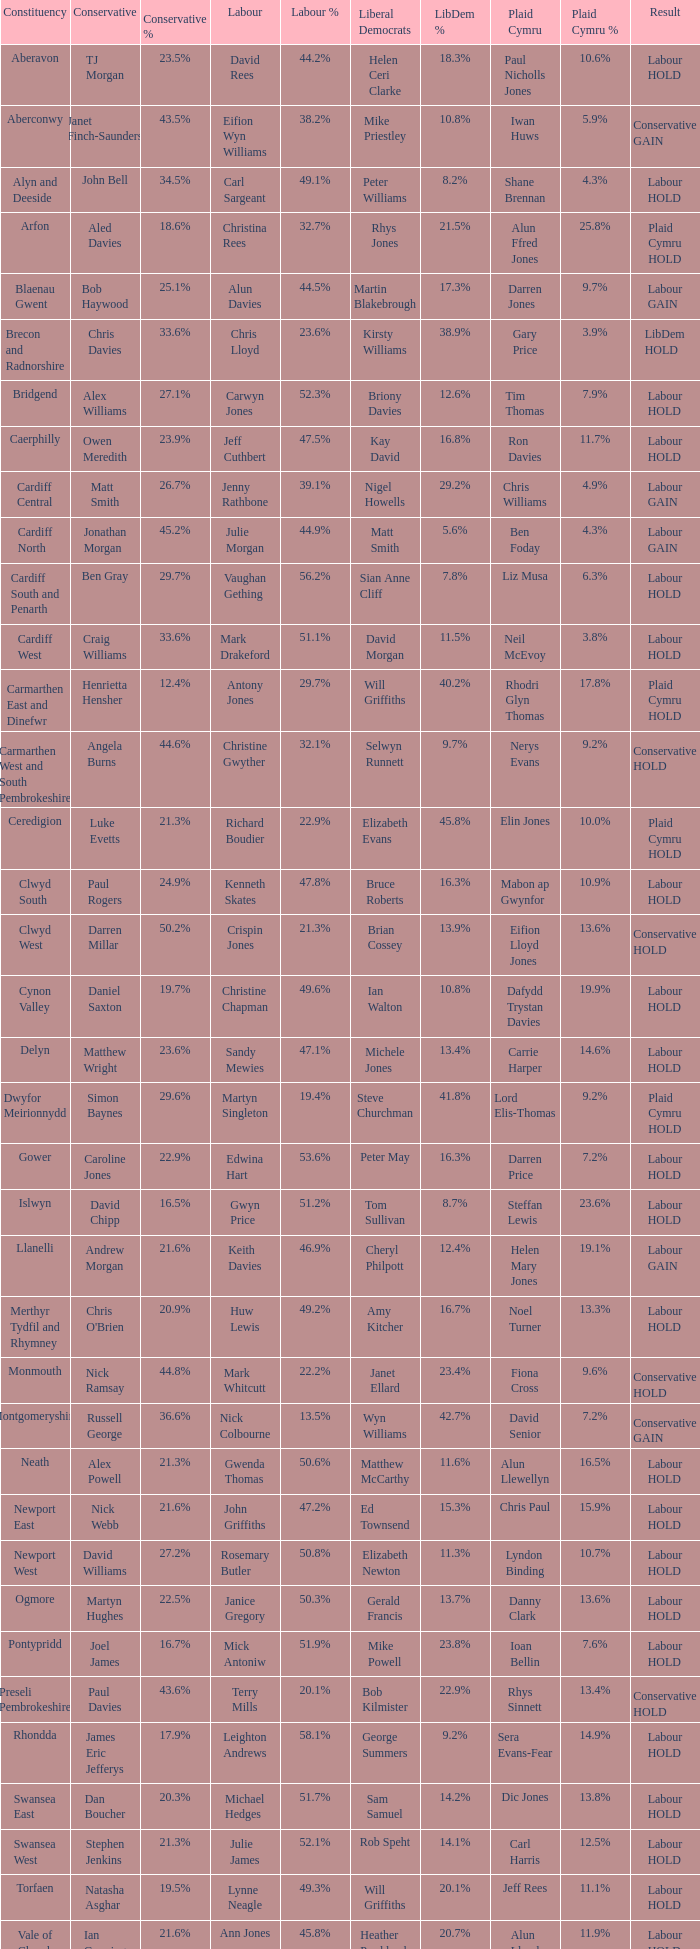What constituency does the Conservative Darren Millar belong to? Clwyd West. 